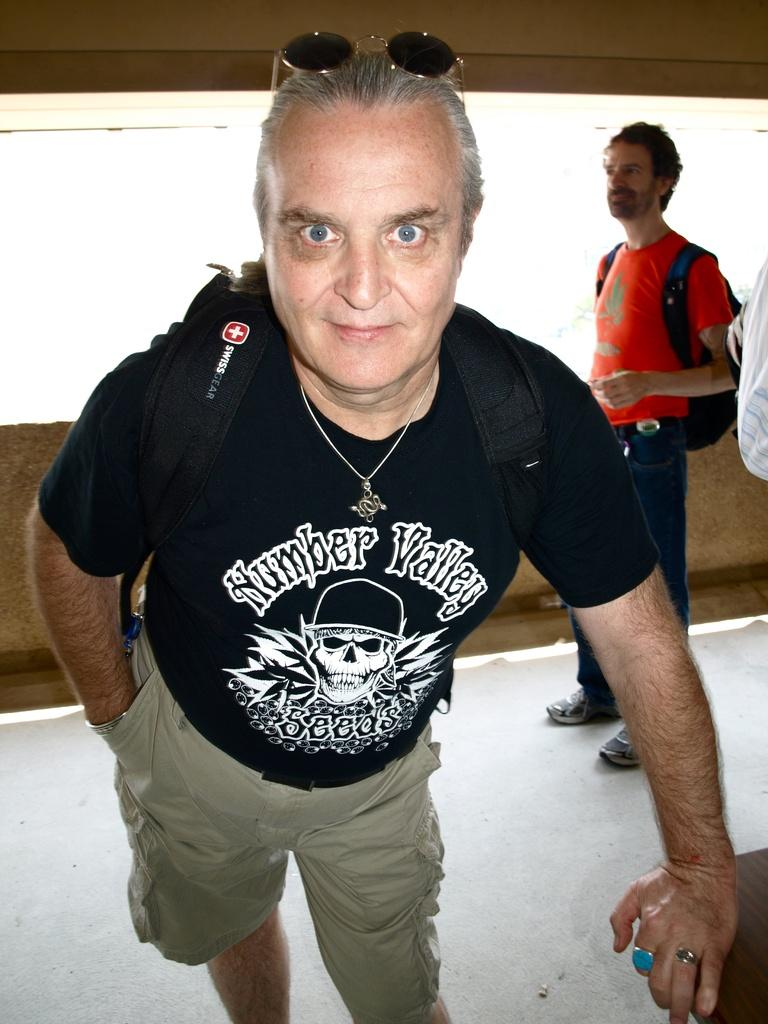<image>
Offer a succinct explanation of the picture presented. Man wearing a Swiss Gear backpack posing for a photo. 